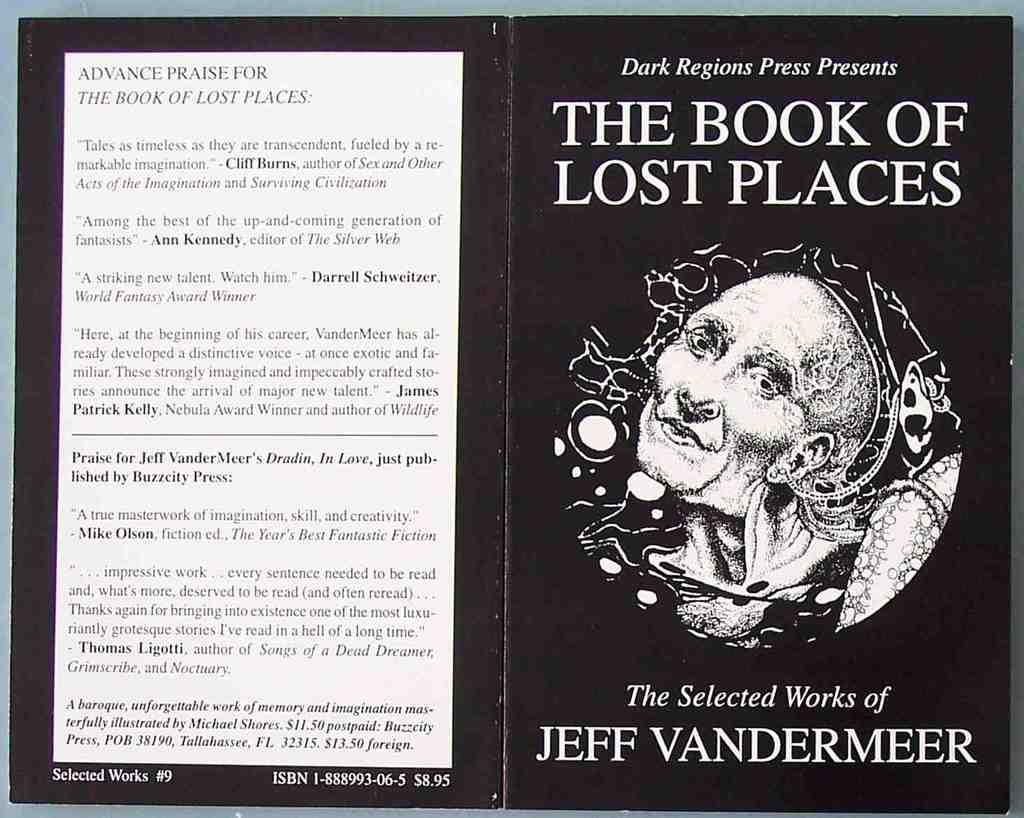<image>
Offer a succinct explanation of the picture presented. The front and back covers of The Book of Lost Places is black and white. 